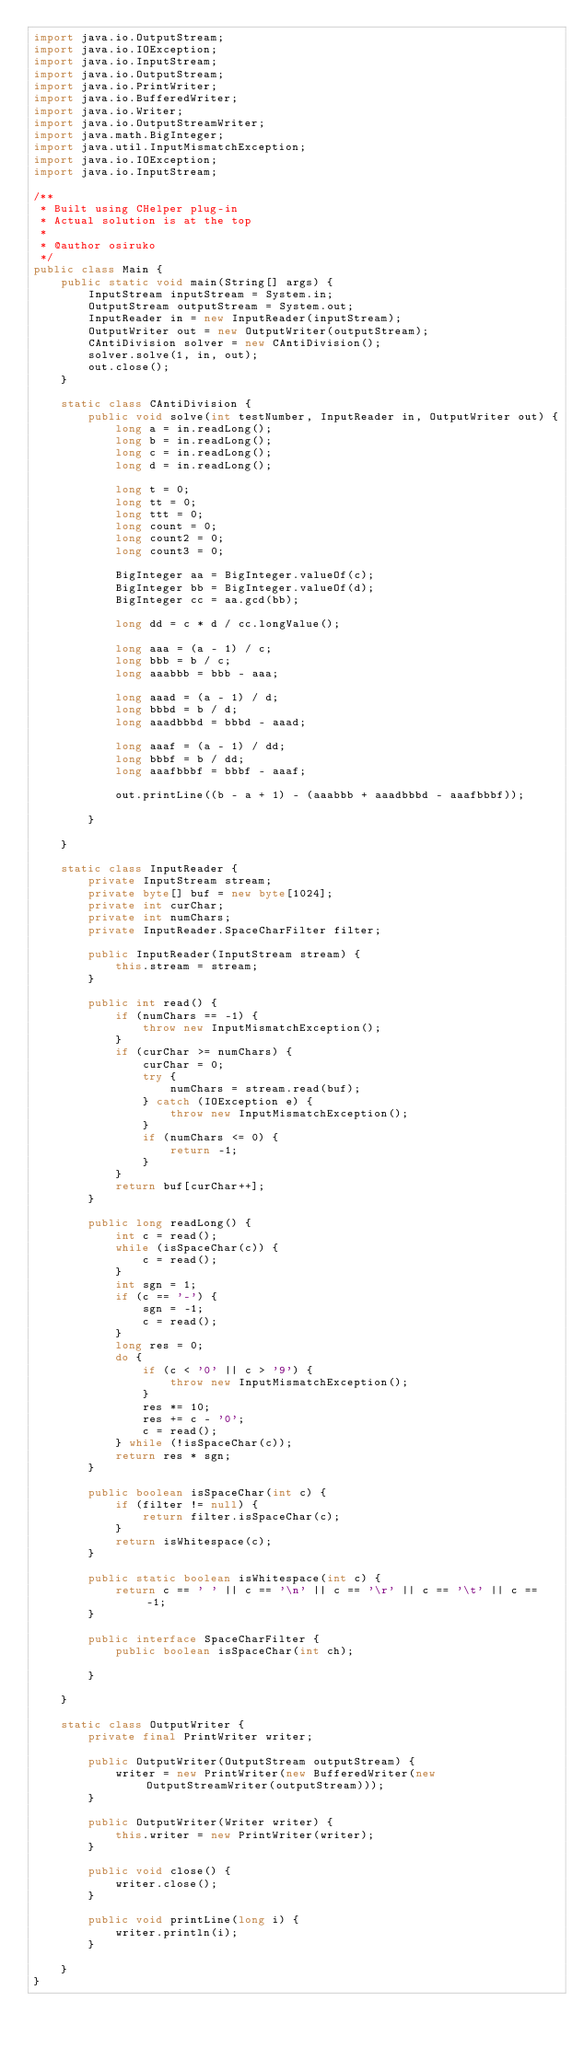<code> <loc_0><loc_0><loc_500><loc_500><_Java_>import java.io.OutputStream;
import java.io.IOException;
import java.io.InputStream;
import java.io.OutputStream;
import java.io.PrintWriter;
import java.io.BufferedWriter;
import java.io.Writer;
import java.io.OutputStreamWriter;
import java.math.BigInteger;
import java.util.InputMismatchException;
import java.io.IOException;
import java.io.InputStream;

/**
 * Built using CHelper plug-in
 * Actual solution is at the top
 *
 * @author osiruko
 */
public class Main {
    public static void main(String[] args) {
        InputStream inputStream = System.in;
        OutputStream outputStream = System.out;
        InputReader in = new InputReader(inputStream);
        OutputWriter out = new OutputWriter(outputStream);
        CAntiDivision solver = new CAntiDivision();
        solver.solve(1, in, out);
        out.close();
    }

    static class CAntiDivision {
        public void solve(int testNumber, InputReader in, OutputWriter out) {
            long a = in.readLong();
            long b = in.readLong();
            long c = in.readLong();
            long d = in.readLong();

            long t = 0;
            long tt = 0;
            long ttt = 0;
            long count = 0;
            long count2 = 0;
            long count3 = 0;

            BigInteger aa = BigInteger.valueOf(c);
            BigInteger bb = BigInteger.valueOf(d);
            BigInteger cc = aa.gcd(bb);

            long dd = c * d / cc.longValue();

            long aaa = (a - 1) / c;
            long bbb = b / c;
            long aaabbb = bbb - aaa;

            long aaad = (a - 1) / d;
            long bbbd = b / d;
            long aaadbbbd = bbbd - aaad;

            long aaaf = (a - 1) / dd;
            long bbbf = b / dd;
            long aaafbbbf = bbbf - aaaf;

            out.printLine((b - a + 1) - (aaabbb + aaadbbbd - aaafbbbf));

        }

    }

    static class InputReader {
        private InputStream stream;
        private byte[] buf = new byte[1024];
        private int curChar;
        private int numChars;
        private InputReader.SpaceCharFilter filter;

        public InputReader(InputStream stream) {
            this.stream = stream;
        }

        public int read() {
            if (numChars == -1) {
                throw new InputMismatchException();
            }
            if (curChar >= numChars) {
                curChar = 0;
                try {
                    numChars = stream.read(buf);
                } catch (IOException e) {
                    throw new InputMismatchException();
                }
                if (numChars <= 0) {
                    return -1;
                }
            }
            return buf[curChar++];
        }

        public long readLong() {
            int c = read();
            while (isSpaceChar(c)) {
                c = read();
            }
            int sgn = 1;
            if (c == '-') {
                sgn = -1;
                c = read();
            }
            long res = 0;
            do {
                if (c < '0' || c > '9') {
                    throw new InputMismatchException();
                }
                res *= 10;
                res += c - '0';
                c = read();
            } while (!isSpaceChar(c));
            return res * sgn;
        }

        public boolean isSpaceChar(int c) {
            if (filter != null) {
                return filter.isSpaceChar(c);
            }
            return isWhitespace(c);
        }

        public static boolean isWhitespace(int c) {
            return c == ' ' || c == '\n' || c == '\r' || c == '\t' || c == -1;
        }

        public interface SpaceCharFilter {
            public boolean isSpaceChar(int ch);

        }

    }

    static class OutputWriter {
        private final PrintWriter writer;

        public OutputWriter(OutputStream outputStream) {
            writer = new PrintWriter(new BufferedWriter(new OutputStreamWriter(outputStream)));
        }

        public OutputWriter(Writer writer) {
            this.writer = new PrintWriter(writer);
        }

        public void close() {
            writer.close();
        }

        public void printLine(long i) {
            writer.println(i);
        }

    }
}

</code> 